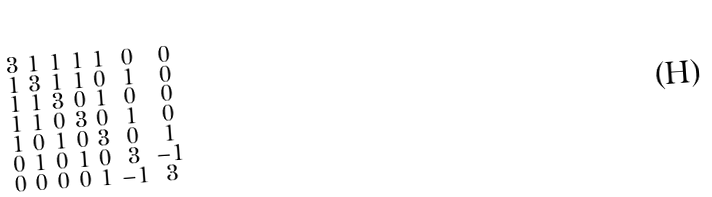Convert formula to latex. <formula><loc_0><loc_0><loc_500><loc_500>\begin{smallmatrix} 3 & 1 & 1 & 1 & 1 & 0 & 0 \\ 1 & 3 & 1 & 1 & 0 & 1 & 0 \\ 1 & 1 & 3 & 0 & 1 & 0 & 0 \\ 1 & 1 & 0 & 3 & 0 & 1 & 0 \\ 1 & 0 & 1 & 0 & 3 & 0 & 1 \\ 0 & 1 & 0 & 1 & 0 & 3 & - 1 \\ 0 & 0 & 0 & 0 & 1 & - 1 & 3 \end{smallmatrix}</formula> 